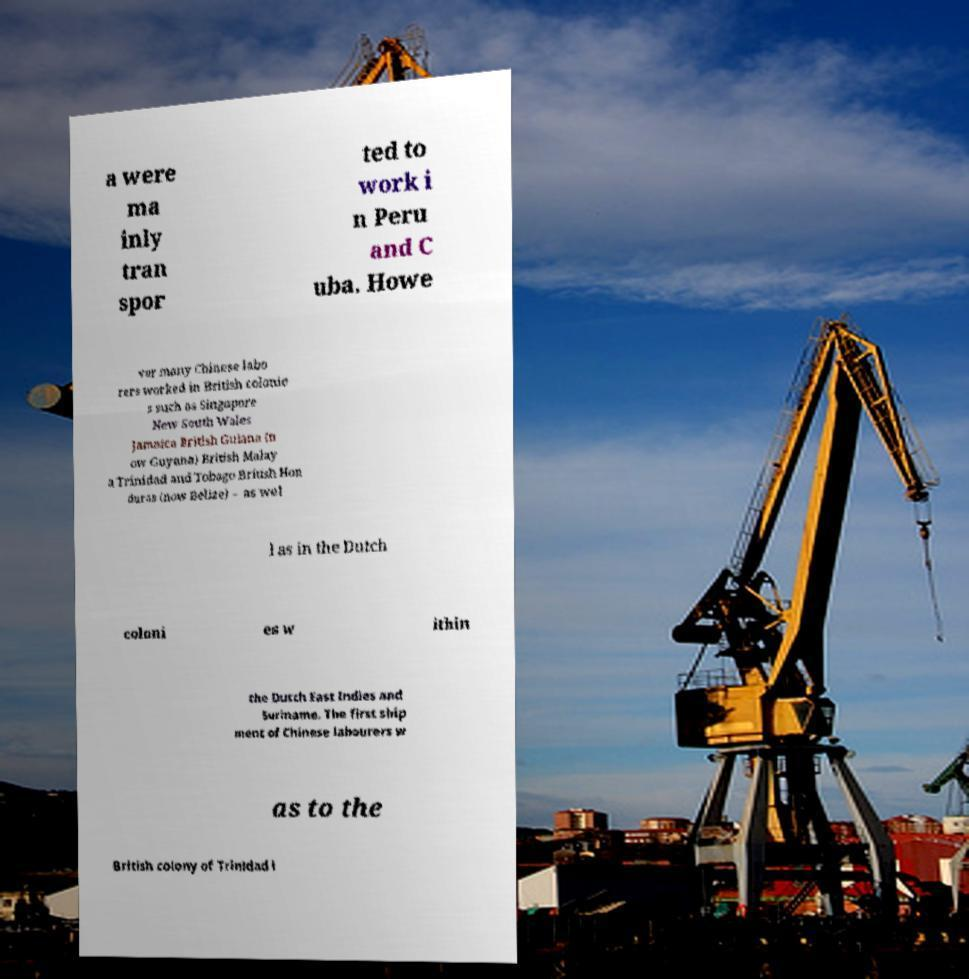For documentation purposes, I need the text within this image transcribed. Could you provide that? a were ma inly tran spor ted to work i n Peru and C uba. Howe ver many Chinese labo rers worked in British colonie s such as Singapore New South Wales Jamaica British Guiana (n ow Guyana) British Malay a Trinidad and Tobago British Hon duras (now Belize) – as wel l as in the Dutch coloni es w ithin the Dutch East Indies and Suriname. The first ship ment of Chinese labourers w as to the British colony of Trinidad i 